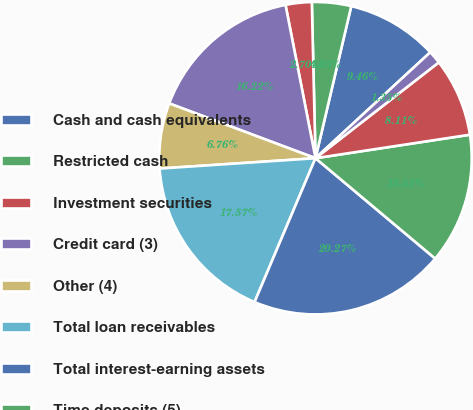Convert chart. <chart><loc_0><loc_0><loc_500><loc_500><pie_chart><fcel>Cash and cash equivalents<fcel>Restricted cash<fcel>Investment securities<fcel>Credit card (3)<fcel>Other (4)<fcel>Total loan receivables<fcel>Total interest-earning assets<fcel>Time deposits (5)<fcel>Savings deposits<fcel>Other interest-bearing<nl><fcel>9.46%<fcel>4.05%<fcel>2.7%<fcel>16.22%<fcel>6.76%<fcel>17.57%<fcel>20.27%<fcel>13.51%<fcel>8.11%<fcel>1.35%<nl></chart> 